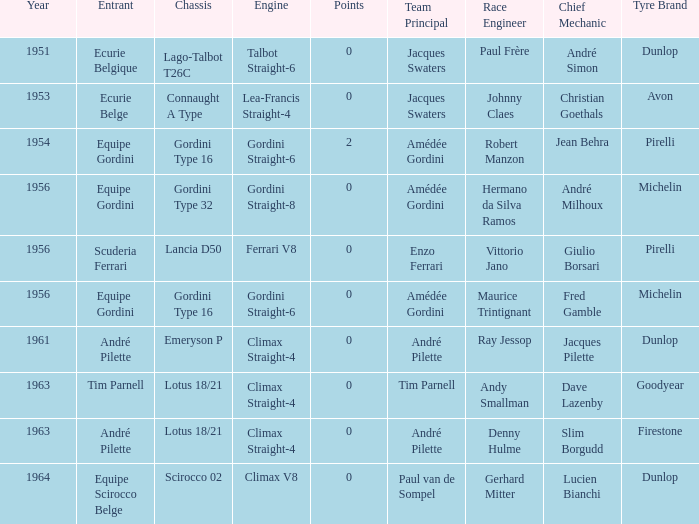Who was in 1963? Tim Parnell, André Pilette. 